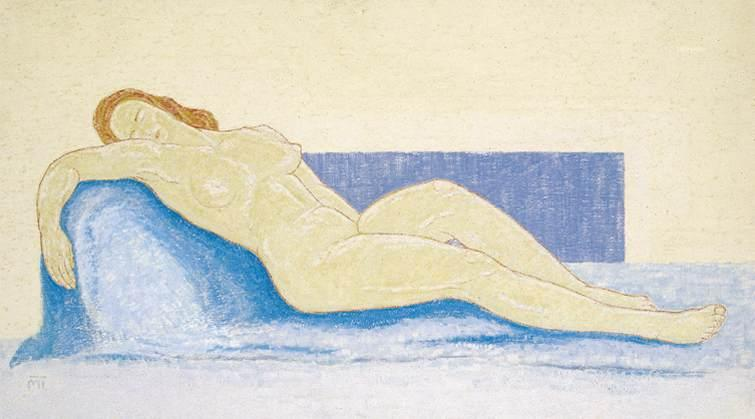Can you describe the color palette used in this artwork in detail? The artist primarily employs a pastel color palette in this artwork, using soft and muted shades to create a tranquil and harmonious scene. The background is a light yellow, evoking a sense of warmth and calm. The blue couch and rectangle behind it introduce cooler tones that contrast gently with the warm background, helping to emphasize the subject's form. The woman's body is rendered in pale, almost translucent skin tones that blend subtly with the couch and background. The overall use of color is delicate and balanced, contributing to the impressionistic style and the serene mood of the scene. 